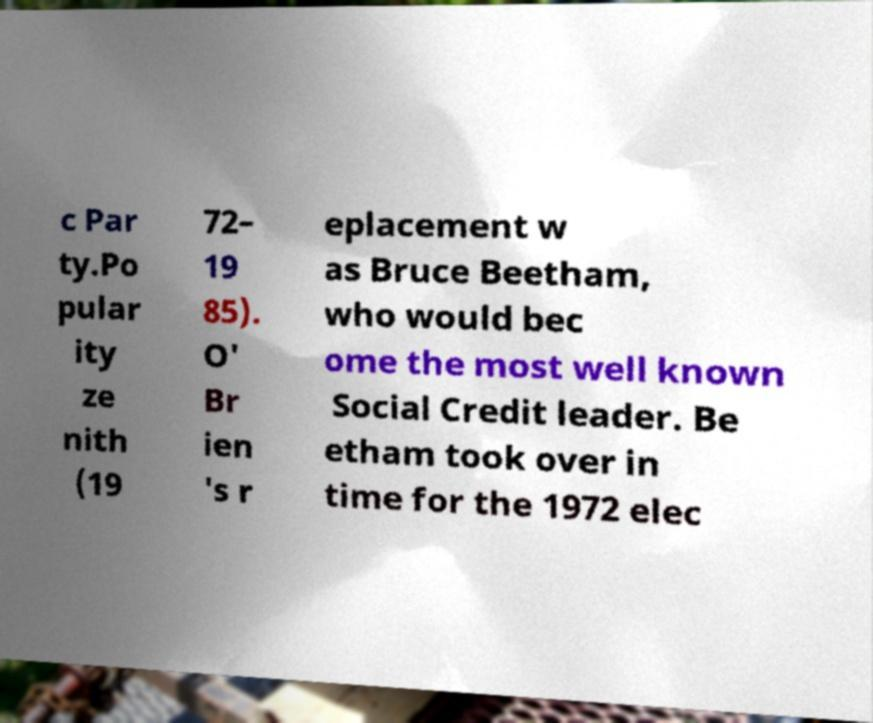I need the written content from this picture converted into text. Can you do that? c Par ty.Po pular ity ze nith (19 72– 19 85). O' Br ien 's r eplacement w as Bruce Beetham, who would bec ome the most well known Social Credit leader. Be etham took over in time for the 1972 elec 